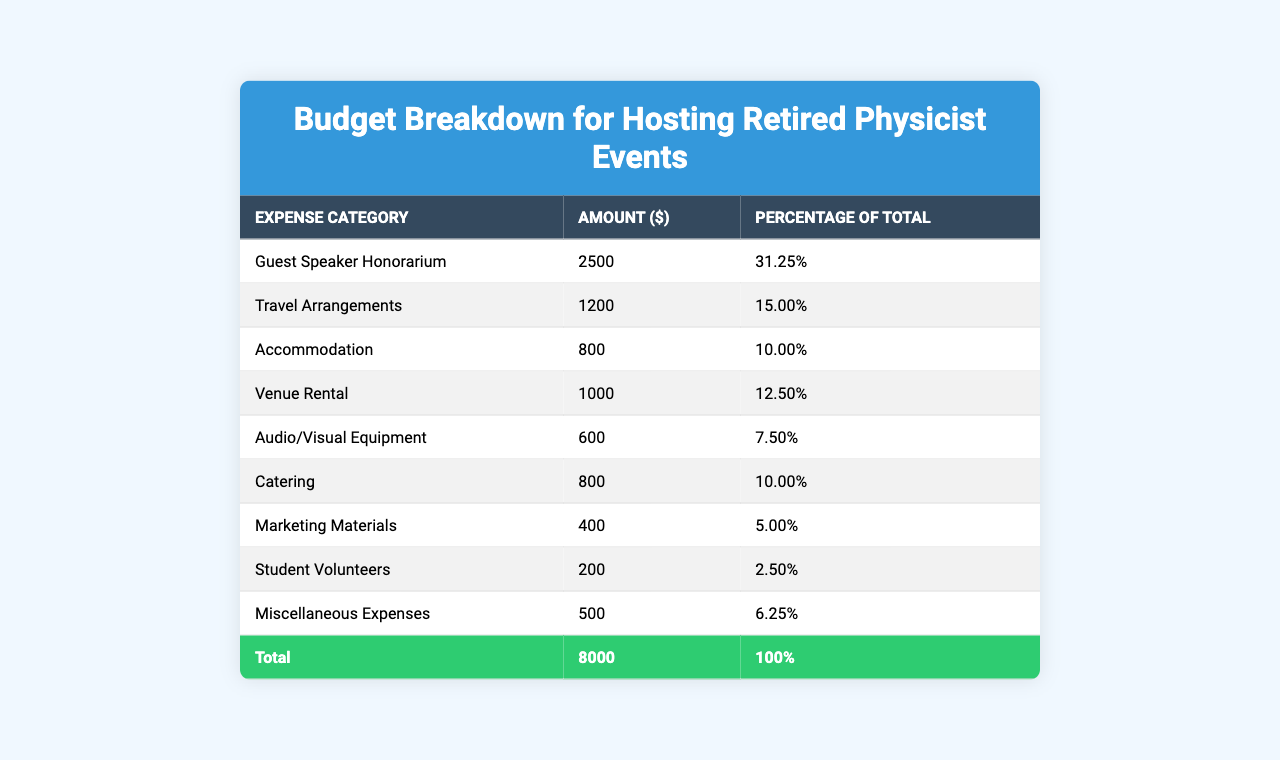What is the total budget for hosting the retired physicist events? The total budget is provided in the last row of the table as "Total," which states the amount is $8000.
Answer: 8000 What percentage of the total budget is allocated for the Guest Speaker Honorarium? The percentage for the Guest Speaker Honorarium can be found in the second column of the respective row, which states it is 31.25%.
Answer: 31.25% Which expense category has the least amount allocated? To determine this, we observe the amounts in the second column. The category with the least amount is "Student Volunteers" with $200.
Answer: Student Volunteers How much is the combined cost for Catering and Accommodation? The amounts for Catering ($800) and Accommodation ($800) should be summed up: 800 + 800 = 1600.
Answer: 1600 Is the amount set aside for Marketing Materials greater than the amount for Audio/Visual Equipment? We compare the amounts: Marketing Materials is $400, and Audio/Visual Equipment is $600. Since 400 is less than 600, the answer is no.
Answer: No What is the difference between the highest and lowest expense categories? The highest expense is the Guest Speaker Honorarium at $2500, and the lowest is Student Volunteers at $200. The difference is calculated as 2500 - 200 = 2300.
Answer: 2300 What percentage of the total budget does Travel Arrangements represent? The percentage for Travel Arrangements can be directly found in the table, which lists it as 15.00%.
Answer: 15.00% Which two categories combined make up more than half of the total budget? The categories "Guest Speaker Honorarium" (31.25%) and "Travel Arrangements" (15.00%) total 46.25%. Adding more categories, "Accommodation" (10.00%) brings the total to 56.25%, which is more than half.
Answer: Guest Speaker Honorarium and Travel Arrangements plus Accommodation How much is dedicated to Miscellaneous Expenses, and what percentage of the total does this represent? The amount for Miscellaneous Expenses in the table is $500, which represents 6.25% of the total budget.
Answer: 500 and 6.25% If we removed the cost of Venue Rental, what would the new total budget be? The original total budget is $8000. Subtracting the Venue Rental cost ($1000) gives us: 8000 - 1000 = 7000.
Answer: 7000 